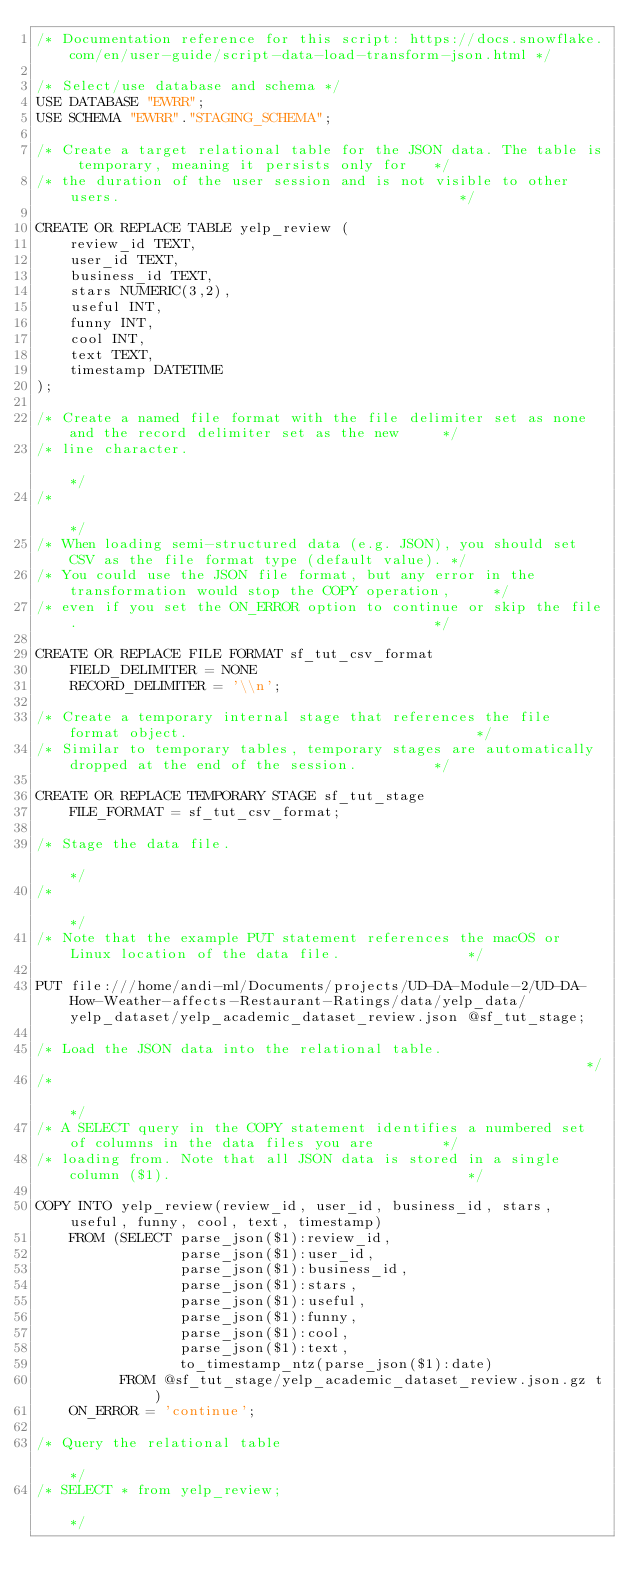Convert code to text. <code><loc_0><loc_0><loc_500><loc_500><_SQL_>/* Documentation reference for this script: https://docs.snowflake.com/en/user-guide/script-data-load-transform-json.html */

/* Select/use database and schema */
USE DATABASE "EWRR";
USE SCHEMA "EWRR"."STAGING_SCHEMA";

/* Create a target relational table for the JSON data. The table is temporary, meaning it persists only for   */
/* the duration of the user session and is not visible to other users.                                        */

CREATE OR REPLACE TABLE yelp_review (
    review_id TEXT,
    user_id TEXT,
    business_id TEXT,
    stars NUMERIC(3,2),
    useful INT,
    funny INT,
    cool INT,
    text TEXT,
    timestamp DATETIME
);

/* Create a named file format with the file delimiter set as none and the record delimiter set as the new     */
/* line character.                                                                                            */
/*                                                                                                            */
/* When loading semi-structured data (e.g. JSON), you should set CSV as the file format type (default value). */
/* You could use the JSON file format, but any error in the transformation would stop the COPY operation,     */
/* even if you set the ON_ERROR option to continue or skip the file.                                          */

CREATE OR REPLACE FILE FORMAT sf_tut_csv_format
    FIELD_DELIMITER = NONE
    RECORD_DELIMITER = '\\n';

/* Create a temporary internal stage that references the file format object.                                  */
/* Similar to temporary tables, temporary stages are automatically dropped at the end of the session.         */

CREATE OR REPLACE TEMPORARY STAGE sf_tut_stage
    FILE_FORMAT = sf_tut_csv_format;

/* Stage the data file.                                                                                       */
/*                                                                                                            */
/* Note that the example PUT statement references the macOS or Linux location of the data file.               */

PUT file:///home/andi-ml/Documents/projects/UD-DA-Module-2/UD-DA-How-Weather-affects-Restaurant-Ratings/data/yelp_data/yelp_dataset/yelp_academic_dataset_review.json @sf_tut_stage;

/* Load the JSON data into the relational table.                                                              */
/*                                                                                                            */
/* A SELECT query in the COPY statement identifies a numbered set of columns in the data files you are        */
/* loading from. Note that all JSON data is stored in a single column ($1).                                   */

COPY INTO yelp_review(review_id, user_id, business_id, stars, useful, funny, cool, text, timestamp)
    FROM (SELECT parse_json($1):review_id,
                 parse_json($1):user_id,
                 parse_json($1):business_id,
                 parse_json($1):stars,
                 parse_json($1):useful,
                 parse_json($1):funny,
                 parse_json($1):cool,
                 parse_json($1):text,
                 to_timestamp_ntz(parse_json($1):date)
          FROM @sf_tut_stage/yelp_academic_dataset_review.json.gz t)
    ON_ERROR = 'continue';

/* Query the relational table                                                                                 */
/* SELECT * from yelp_review;                                                                                 */</code> 